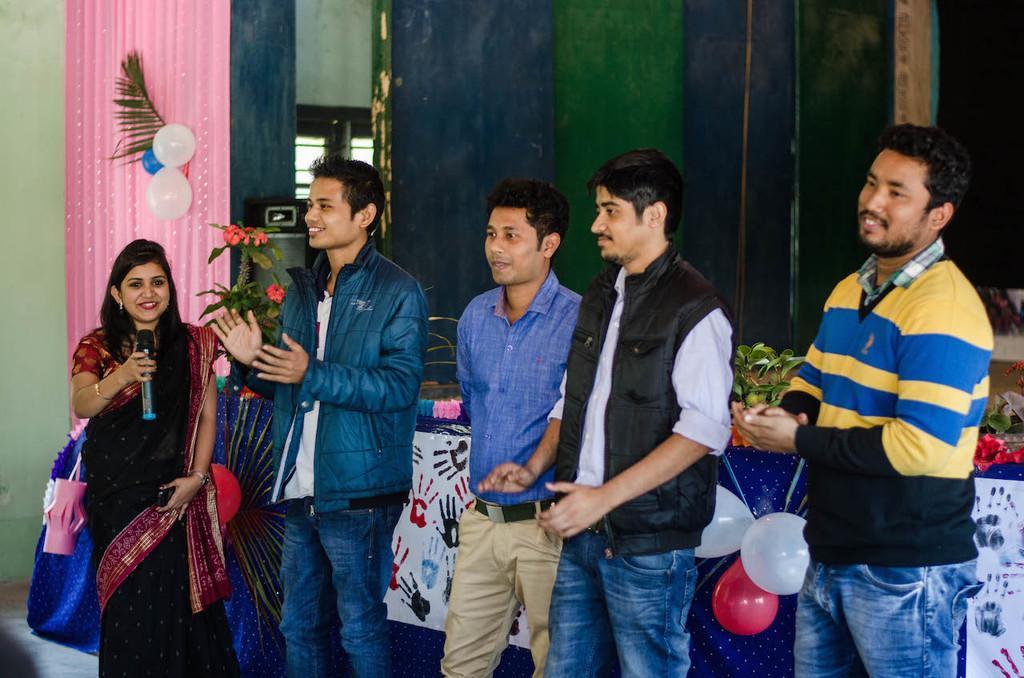Describe this image in one or two sentences. In this image I can see five persons standing. There is a wall, a door and a mike. Also there are balloons, flowers, plants, decorative items and some other objects. 